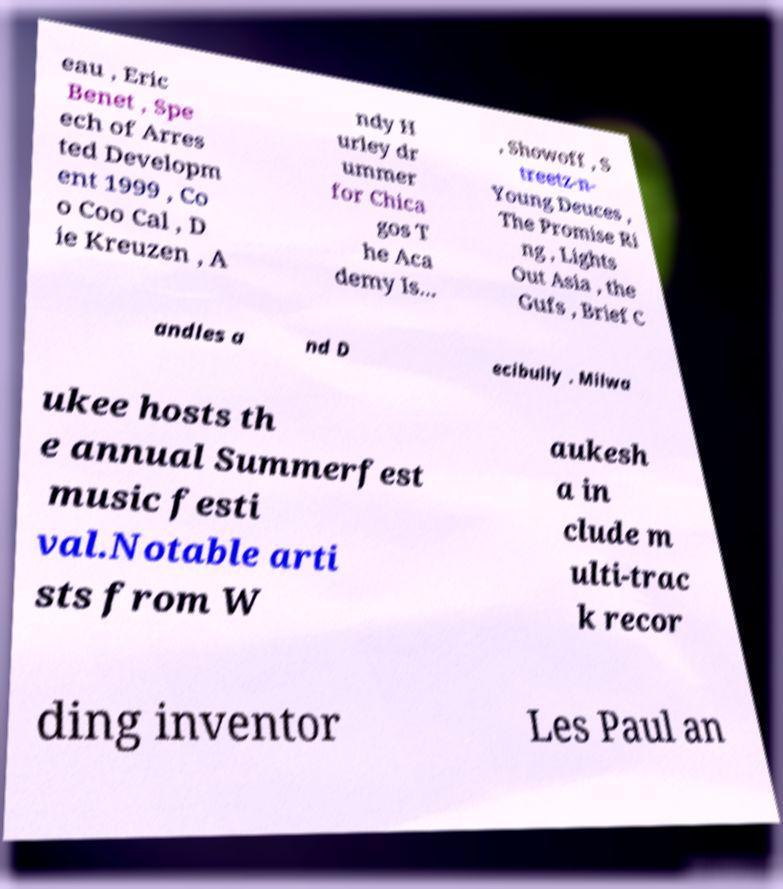Could you extract and type out the text from this image? eau , Eric Benet , Spe ech of Arres ted Developm ent 1999 , Co o Coo Cal , D ie Kreuzen , A ndy H urley dr ummer for Chica gos T he Aca demy Is... , Showoff , S treetz-n- Young Deuces , The Promise Ri ng , Lights Out Asia , the Gufs , Brief C andles a nd D ecibully . Milwa ukee hosts th e annual Summerfest music festi val.Notable arti sts from W aukesh a in clude m ulti-trac k recor ding inventor Les Paul an 